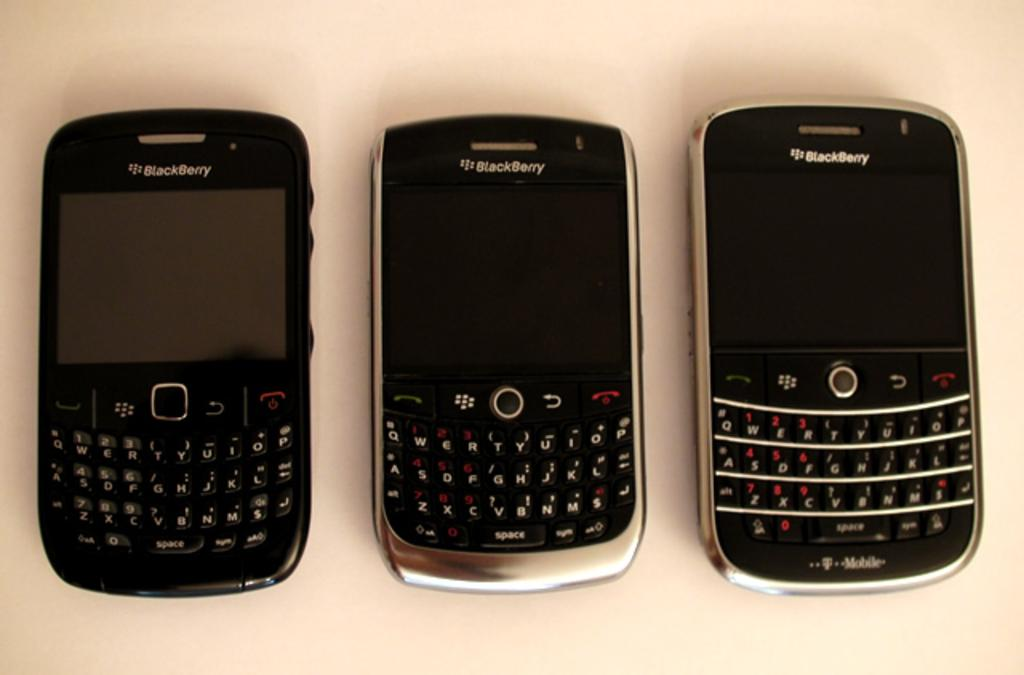<image>
Offer a succinct explanation of the picture presented. some phones that say Blackberry on the front 